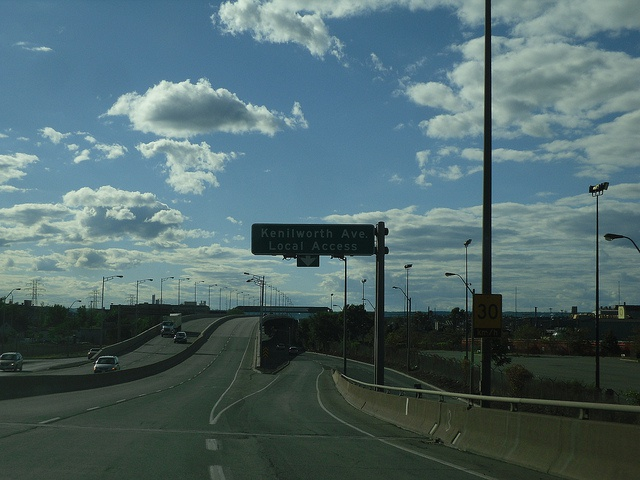Describe the objects in this image and their specific colors. I can see truck in gray, black, and teal tones, car in gray, black, and teal tones, car in gray, black, teal, and darkgray tones, car in gray, black, teal, and darkgray tones, and car in gray and black tones in this image. 